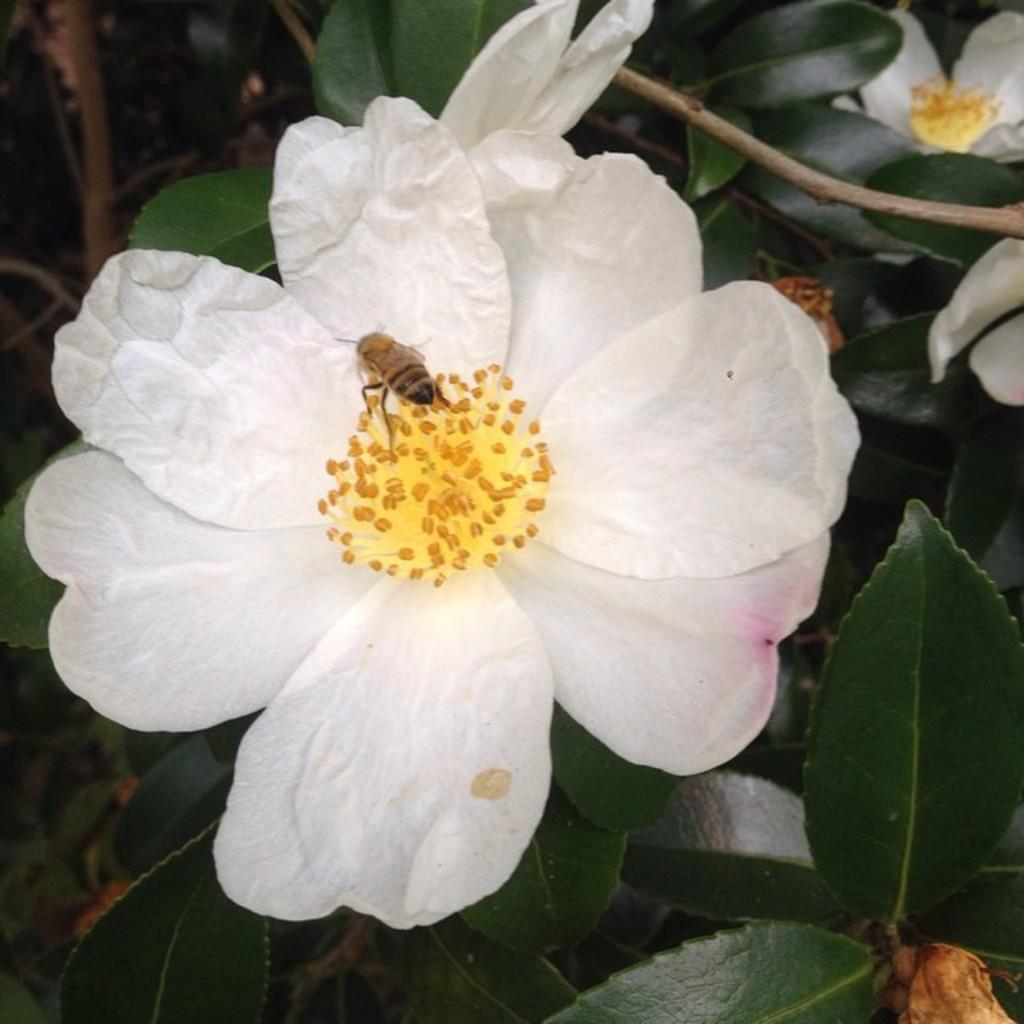What type of insect is present in the image? There is a bee in the image. What is the bee doing in the image? The bee is sitting on a flower. Where is the flower located in the image? The flower is on a plant. What type of apparel is the stranger wearing in the image? There is no stranger present in the image, so it is not possible to determine what type of apparel they might be wearing. 